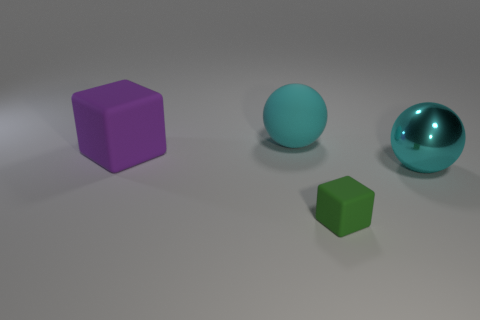Does the metal sphere have the same color as the large rubber ball?
Ensure brevity in your answer.  Yes. How many small brown cylinders are the same material as the big purple block?
Keep it short and to the point. 0. What color is the big ball that is the same material as the green block?
Ensure brevity in your answer.  Cyan. Is the size of the matte cube that is to the right of the cyan rubber object the same as the large purple cube?
Give a very brief answer. No. What color is the other tiny rubber thing that is the same shape as the purple object?
Offer a very short reply. Green. The cyan thing that is behind the big ball in front of the cube to the left of the rubber sphere is what shape?
Ensure brevity in your answer.  Sphere. Is the shape of the purple thing the same as the green thing?
Provide a short and direct response. Yes. What is the shape of the large thing that is to the left of the large cyan object on the left side of the tiny cube?
Make the answer very short. Cube. Are any small yellow matte objects visible?
Provide a succinct answer. No. How many purple things are on the left side of the shiny thing in front of the cyan object to the left of the large cyan metal thing?
Keep it short and to the point. 1. 